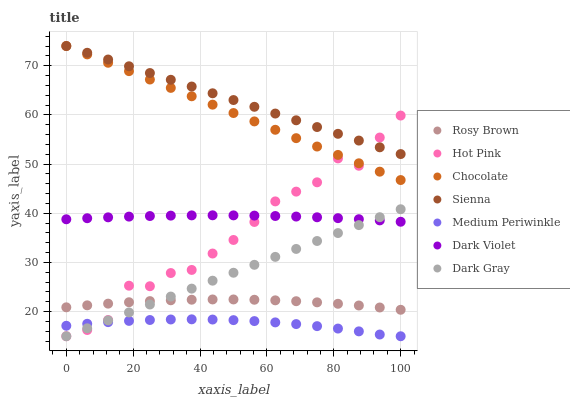Does Medium Periwinkle have the minimum area under the curve?
Answer yes or no. Yes. Does Sienna have the maximum area under the curve?
Answer yes or no. Yes. Does Hot Pink have the minimum area under the curve?
Answer yes or no. No. Does Hot Pink have the maximum area under the curve?
Answer yes or no. No. Is Dark Gray the smoothest?
Answer yes or no. Yes. Is Hot Pink the roughest?
Answer yes or no. Yes. Is Rosy Brown the smoothest?
Answer yes or no. No. Is Rosy Brown the roughest?
Answer yes or no. No. Does Dark Gray have the lowest value?
Answer yes or no. Yes. Does Rosy Brown have the lowest value?
Answer yes or no. No. Does Sienna have the highest value?
Answer yes or no. Yes. Does Hot Pink have the highest value?
Answer yes or no. No. Is Medium Periwinkle less than Rosy Brown?
Answer yes or no. Yes. Is Sienna greater than Dark Gray?
Answer yes or no. Yes. Does Hot Pink intersect Medium Periwinkle?
Answer yes or no. Yes. Is Hot Pink less than Medium Periwinkle?
Answer yes or no. No. Is Hot Pink greater than Medium Periwinkle?
Answer yes or no. No. Does Medium Periwinkle intersect Rosy Brown?
Answer yes or no. No. 